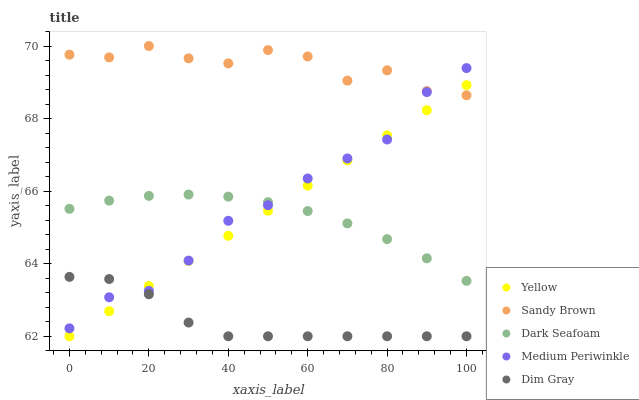Does Dim Gray have the minimum area under the curve?
Answer yes or no. Yes. Does Sandy Brown have the maximum area under the curve?
Answer yes or no. Yes. Does Dark Seafoam have the minimum area under the curve?
Answer yes or no. No. Does Dark Seafoam have the maximum area under the curve?
Answer yes or no. No. Is Yellow the smoothest?
Answer yes or no. Yes. Is Sandy Brown the roughest?
Answer yes or no. Yes. Is Dark Seafoam the smoothest?
Answer yes or no. No. Is Dark Seafoam the roughest?
Answer yes or no. No. Does Dim Gray have the lowest value?
Answer yes or no. Yes. Does Dark Seafoam have the lowest value?
Answer yes or no. No. Does Sandy Brown have the highest value?
Answer yes or no. Yes. Does Dark Seafoam have the highest value?
Answer yes or no. No. Is Dark Seafoam less than Sandy Brown?
Answer yes or no. Yes. Is Sandy Brown greater than Dim Gray?
Answer yes or no. Yes. Does Sandy Brown intersect Yellow?
Answer yes or no. Yes. Is Sandy Brown less than Yellow?
Answer yes or no. No. Is Sandy Brown greater than Yellow?
Answer yes or no. No. Does Dark Seafoam intersect Sandy Brown?
Answer yes or no. No. 